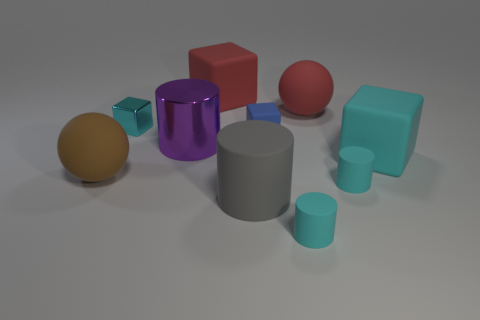What can be inferred about the lighting in this scene? The lighting in this scene is diffused, creating soft-edged shadows, which suggests a single, not overly harsh light source from the upper left perspective. Does the composition of the objects suggest any particular theme or purpose? The arrangement of geometric shapes appears random, lacking a discernible pattern or purpose, which might indicate that this scene is constructed for the purpose of a visual or spatial study rather than to convey a thematic message. 